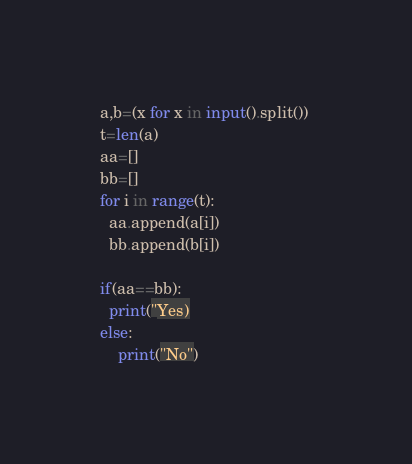<code> <loc_0><loc_0><loc_500><loc_500><_Python_>a,b=(x for x in input().split()) 
t=len(a)
aa=[]
bb=[]
for i in range(t):
  aa.append(a[i])
  bb.append(b[i])
 
if(aa==bb):
  print("Yes)
else:
	print("No")</code> 